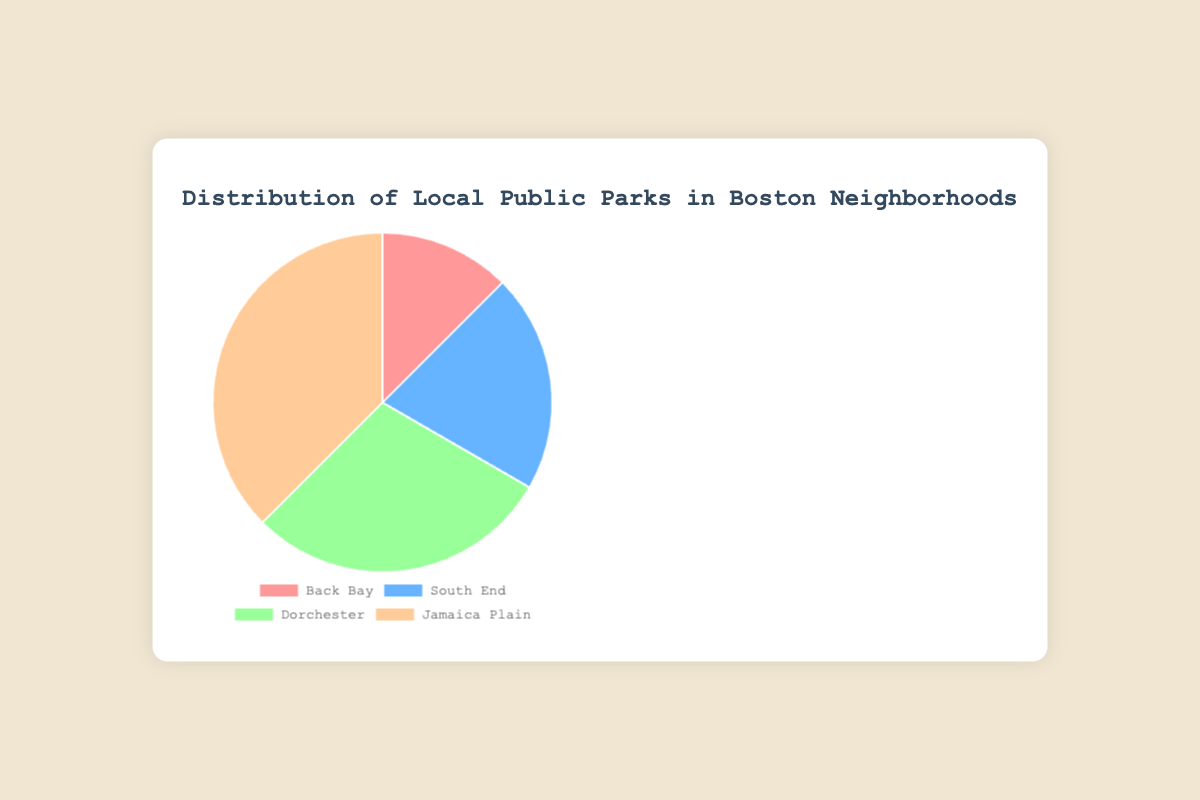What percentage of the total parks are in Jamaica Plain? First, sum the total number of parks: 3 (Back Bay) + 5 (South End) + 7 (Dorchester) + 9 (Jamaica Plain) = 24 parks. Then, find the percentage for Jamaica Plain: (9/24) * 100 = 37.5%
Answer: 37.5% How many more parks does Dorchester have compared to Back Bay? Dorchester has 7 parks and Back Bay has 3 parks. The difference is 7 - 3 = 4 parks
Answer: 4 Which neighborhood has the fewest parks? According to the chart, Back Bay has the fewest number of parks with 3 parks
Answer: Back Bay What is the total number of parks in South End and Dorchester combined? Calculate the sum of parks in South End and Dorchester: 5 (South End) + 7 (Dorchester) = 12 parks
Answer: 12 Which neighborhood has the highest number of parks? According to the chart, Jamaica Plain has the highest number of parks with 9 parks
Answer: Jamaica Plain What is the difference in the number of parks between the neighborhood with the most parks and the neighborhood with the fewest parks? Jamaica Plain has the most parks with 9 parks, and Back Bay has the fewest parks with 3 parks. The difference is 9 - 3 = 6 parks
Answer: 6 What proportion of the total number of parks does South End have? Sum the total number of parks: 3 (Back Bay) + 5 (South End) + 7 (Dorchester) + 9 (Jamaica Plain) = 24 parks. Compute the proportion for South End: 5/24 = 0.2083
Answer: 0.2083 If a new park is added to Dorchester, how many parks will Dorchester have, and will it still be less than Jamaica Plain? Adding 1 park to Dorchester would result in 7 + 1 = 8 parks. Jamaica Plain has 9 parks, so Dorchester will still have fewer parks than Jamaica Plain
Answer: 8 parks; Yes What is the sum of the parks in Back Bay and Jamaica Plain? Calculate the total number of parks by adding Back Bay and Jamaica Plain: 3 (Back Bay) + 9 (Jamaica Plain) = 12 parks
Answer: 12 